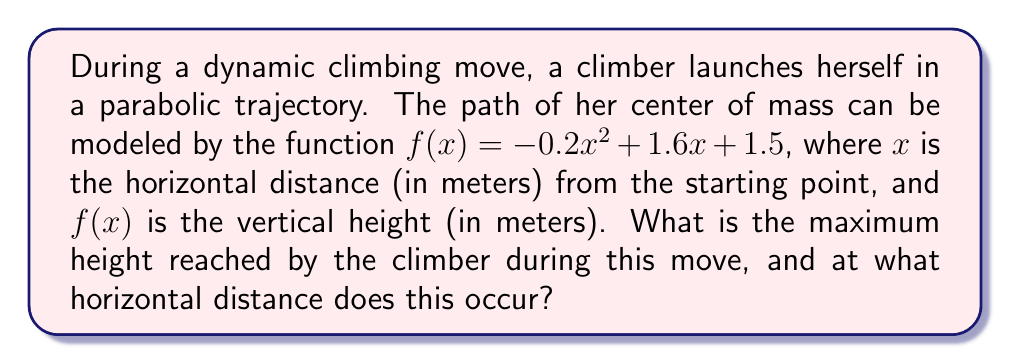Show me your answer to this math problem. To solve this problem, we'll follow these steps:

1) The function $f(x) = -0.2x^2 + 1.6x + 1.5$ is a quadratic function, which forms a parabola. The maximum point of a parabola occurs at its vertex.

2) For a quadratic function in the form $f(x) = ax^2 + bx + c$, the x-coordinate of the vertex is given by $x = -\frac{b}{2a}$.

3) In our case, $a = -0.2$ and $b = 1.6$. Let's calculate the x-coordinate of the vertex:

   $x = -\frac{1.6}{2(-0.2)} = -\frac{1.6}{-0.4} = 4$

4) This means the maximum height occurs when $x = 4$ meters.

5) To find the maximum height, we need to calculate $f(4)$:

   $f(4) = -0.2(4)^2 + 1.6(4) + 1.5$
   $    = -0.2(16) + 6.4 + 1.5$
   $    = -3.2 + 6.4 + 1.5$
   $    = 4.7$

Therefore, the maximum height is 4.7 meters.
Answer: Maximum height: 4.7 m; occurs at x = 4 m 